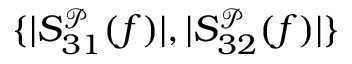Convert formula to latex. <formula><loc_0><loc_0><loc_500><loc_500>\{ | S _ { 3 1 } ^ { \mathcal { P } } ( f ) | , | S _ { 3 2 } ^ { \mathcal { P } } ( f ) | \}</formula> 